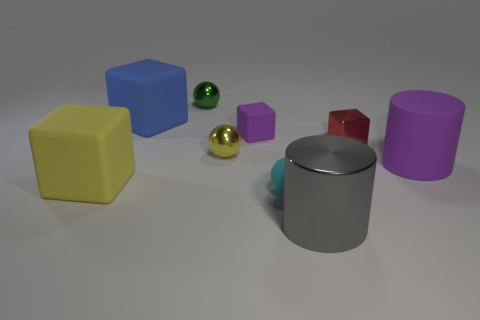What is the shape of the tiny shiny object that is in front of the small block that is to the right of the big cylinder that is in front of the tiny rubber sphere?
Your answer should be very brief. Sphere. Is the shape of the object left of the blue matte block the same as the small shiny object behind the blue rubber cube?
Your answer should be compact. No. What number of other objects are there of the same material as the purple cylinder?
Offer a very short reply. 4. What shape is the big purple object that is the same material as the small cyan sphere?
Provide a succinct answer. Cylinder. Does the cyan object have the same size as the yellow metallic thing?
Ensure brevity in your answer.  Yes. How big is the ball that is in front of the rubber block in front of the big purple cylinder?
Make the answer very short. Small. There is a big thing that is the same color as the small matte block; what is its shape?
Offer a terse response. Cylinder. How many balls are either red objects or metal things?
Offer a terse response. 2. There is a matte ball; is its size the same as the cylinder behind the shiny cylinder?
Offer a terse response. No. Are there more big purple rubber objects that are behind the tiny red thing than red metal blocks?
Your answer should be compact. No. 